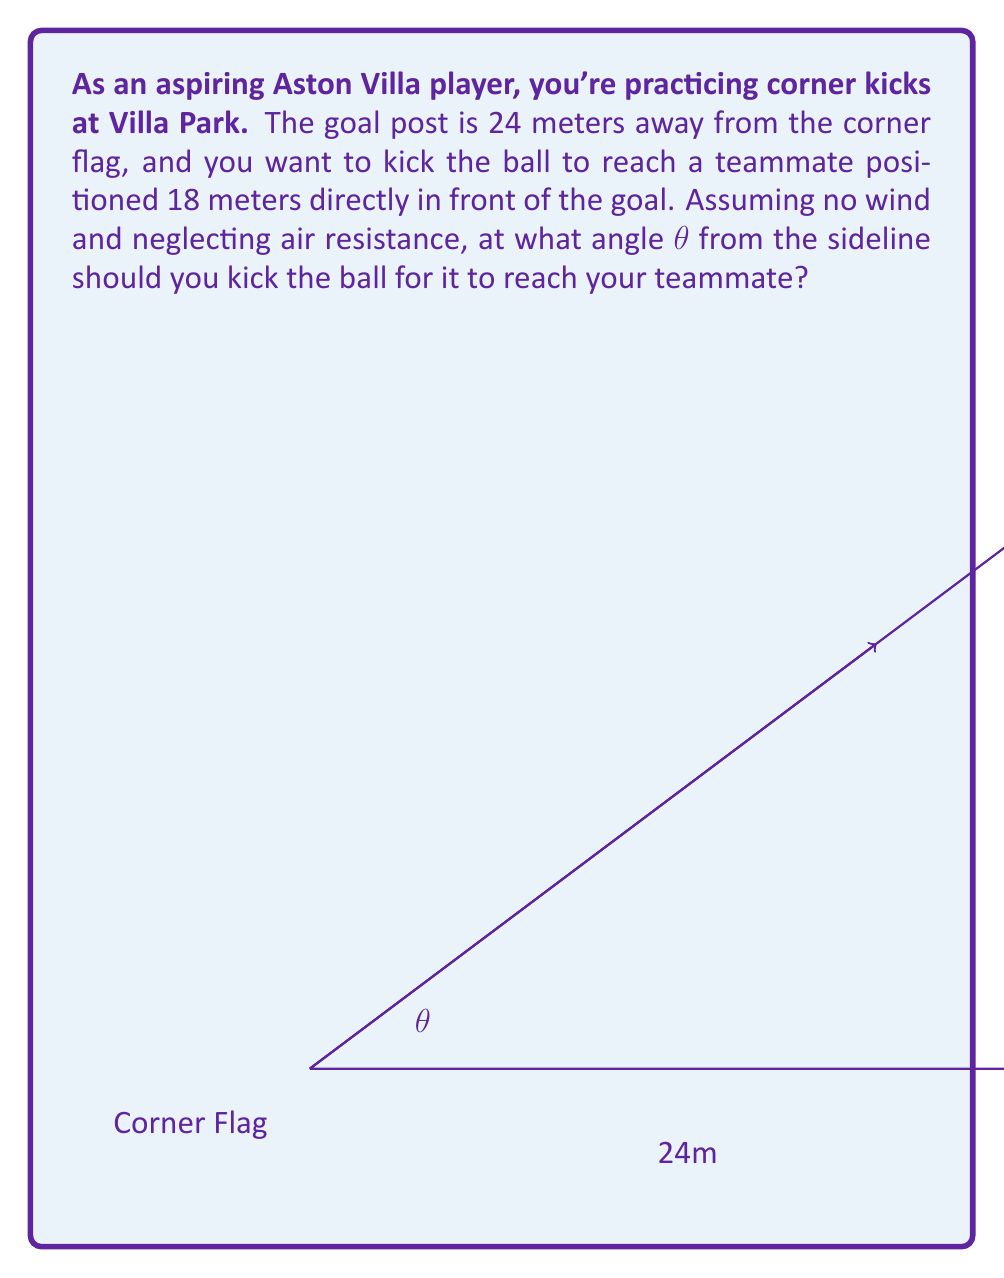Solve this math problem. Let's approach this step-by-step using vector components:

1) We can treat this as a 2D vector problem. Let the corner flag be the origin (0,0), the x-axis along the goal line, and the y-axis perpendicular to it.

2) The goal post is at (24,0) and the teammate is at (24,18).

3) The vector from the corner flag to the teammate is:
   $$\vec{v} = (24, 18)$$

4) The magnitude of this vector is:
   $$|\vec{v}| = \sqrt{24^2 + 18^2} = \sqrt{900} = 30$$

5) The angle θ we're looking for is the angle between this vector and the x-axis (goal line).

6) We can find this using the arctangent function:
   $$\theta = \arctan(\frac{y}{x}) = \arctan(\frac{18}{24})$$

7) Simplifying the fraction:
   $$\theta = \arctan(\frac{3}{4})$$

8) Calculate the angle:
   $$\theta \approx 36.87°$$

Therefore, you should kick the ball at an angle of approximately 36.87° from the sideline.
Answer: $\theta = \arctan(\frac{3}{4}) \approx 36.87°$ 